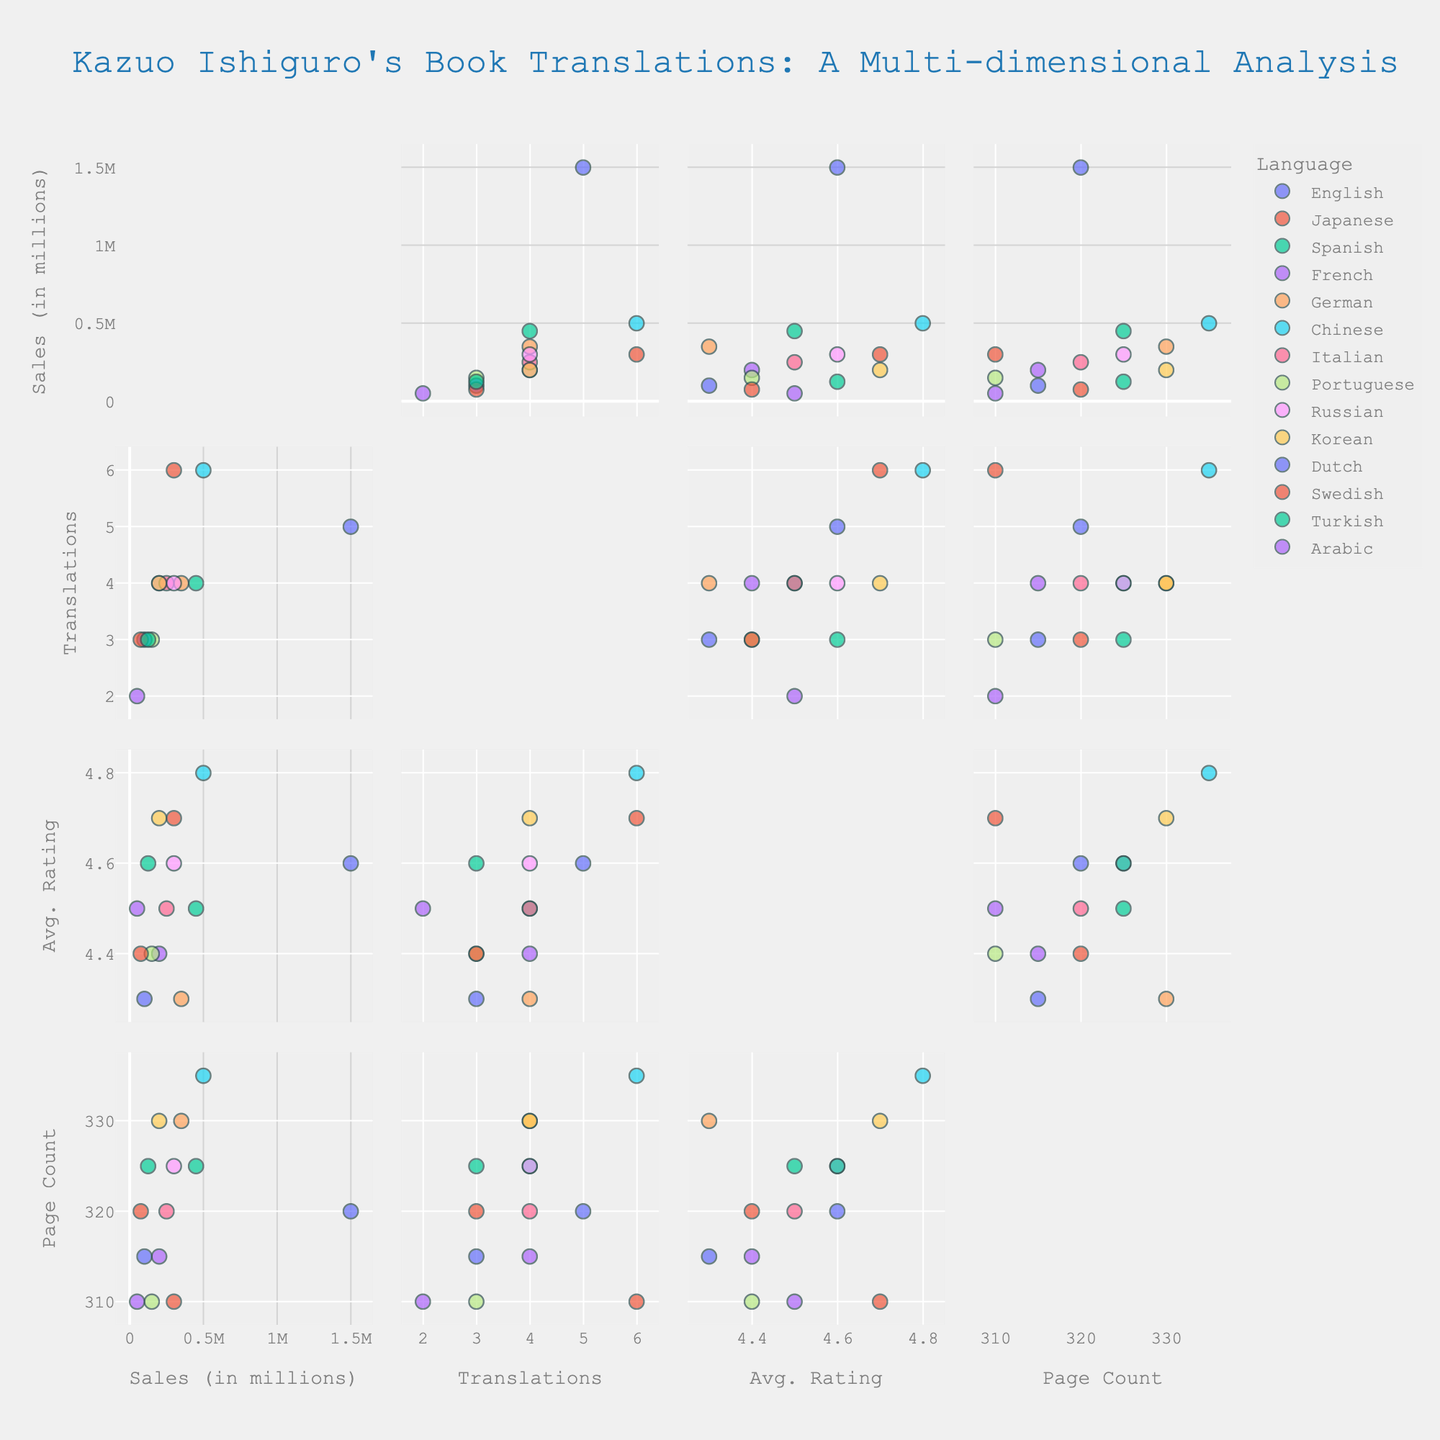what is the title of the figure? The figure's title is displayed at the top of the scatter plot matrix. The title is directly given in the rendered image and describes the main focus of the analysis.
Answer: "Kazuo Ishiguro's Book Translations: A Multi-dimensional Analysis" what are the dimensions represented in the scatter plot matrix? The dimensions are listed in the labels and represent the axes of the scatter plot matrix. You can see the dimensions labeled on both the x and y axes of the subplots.
Answer: Sales, Number_of_Translations, Average_Ratings, Number_of_Pages how many languages does the figure display data for? Each data point is represented by a different color in the scatter plot matrix, and each color corresponds to a different language. Count the number of unique labels in the legend.
Answer: 14 languages which language has the highest sales? Find the data point with the highest position on the 'Sales' axis in the relevant subplot, and identify the corresponding language from the color or tooltip.
Answer: English which language has the lowest average rating? Identify the lowest position on the 'Average_Ratings' axis in the relevant subplot, and then determine the corresponding language based on the color or tooltip.
Answer: Dutch how many languages have more than 4 translations? Look at the 'Number_of_Translations' axis and count the number of data points that are above 4. Check the corresponding languages in the legend or tooltip.
Answer: 3 languages (Japanese, Chinese, English) what is the average page count for languages with exactly 4 translations? Identify the data points where 'Number_of_Translations' equals 4, then find the associated 'Number_of_Pages' values and calculate their average.
Answer: (325 + 315 + 330 + 325 + 330) / 5 = 325 which language has a higher average rating: Spanish or German? Find the positions of the Spanish and German data points on the 'Average_Ratings' axis and compare their values.
Answer: Spanish what is the relationship between average ratings and sales for the Chinese language? Locate the Chinese data point in the subplots that compare 'Average_Ratings' and 'Sales', and observe if the rating increases or decreases with sales.
Answer: Positive correlation is there any language with both high sales and high average ratings? Look at subplots combining 'Sales' and 'Average_Ratings'. Identify any languages that are towards the top right end, indicating high values in both dimensions.
Answer: Chinese 